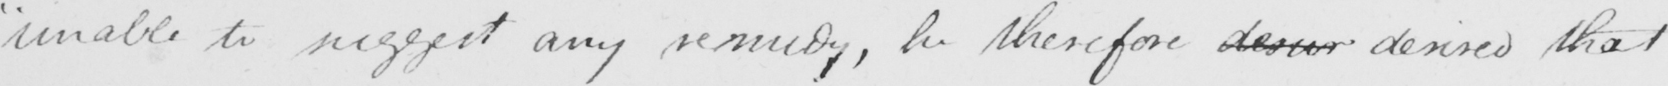What text is written in this handwritten line? " unable to suggest any remedy , he therefore desure desired that 